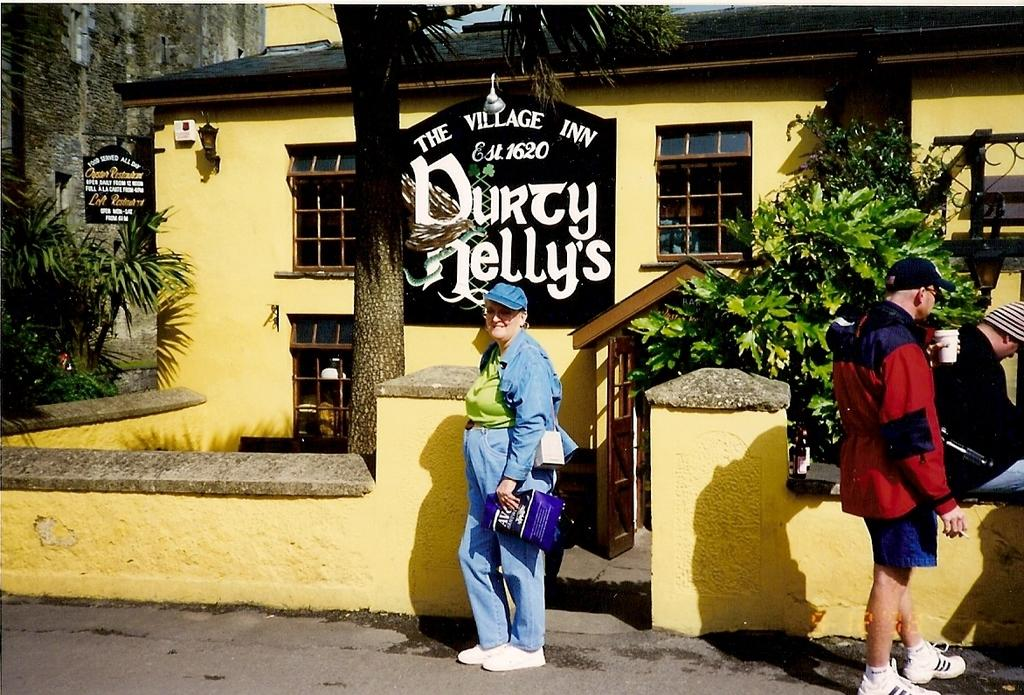What are the people in the middle of the image doing? The people in the middle of the image are standing and holding cups and bags. What can be seen behind the people? There is a wall behind the people, and trees and plants are visible behind the wall. What is in the background of the image? There are buildings in the background of the image. Where is the playground located in the image? There is no playground present in the image. What type of fork is being used by the people in the image? There are no forks visible in the image; the people are holding cups and bags. 